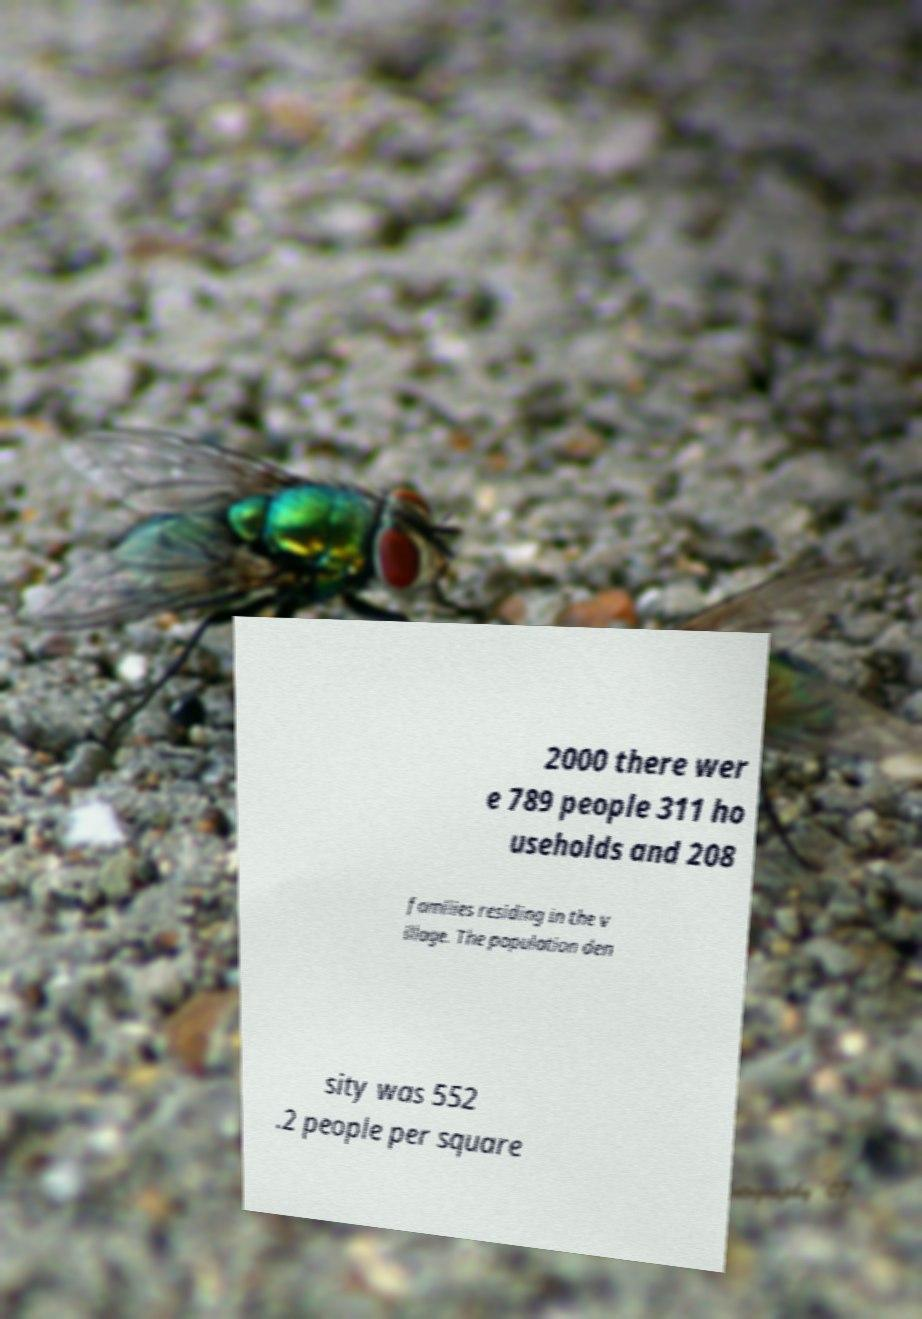Could you assist in decoding the text presented in this image and type it out clearly? 2000 there wer e 789 people 311 ho useholds and 208 families residing in the v illage. The population den sity was 552 .2 people per square 